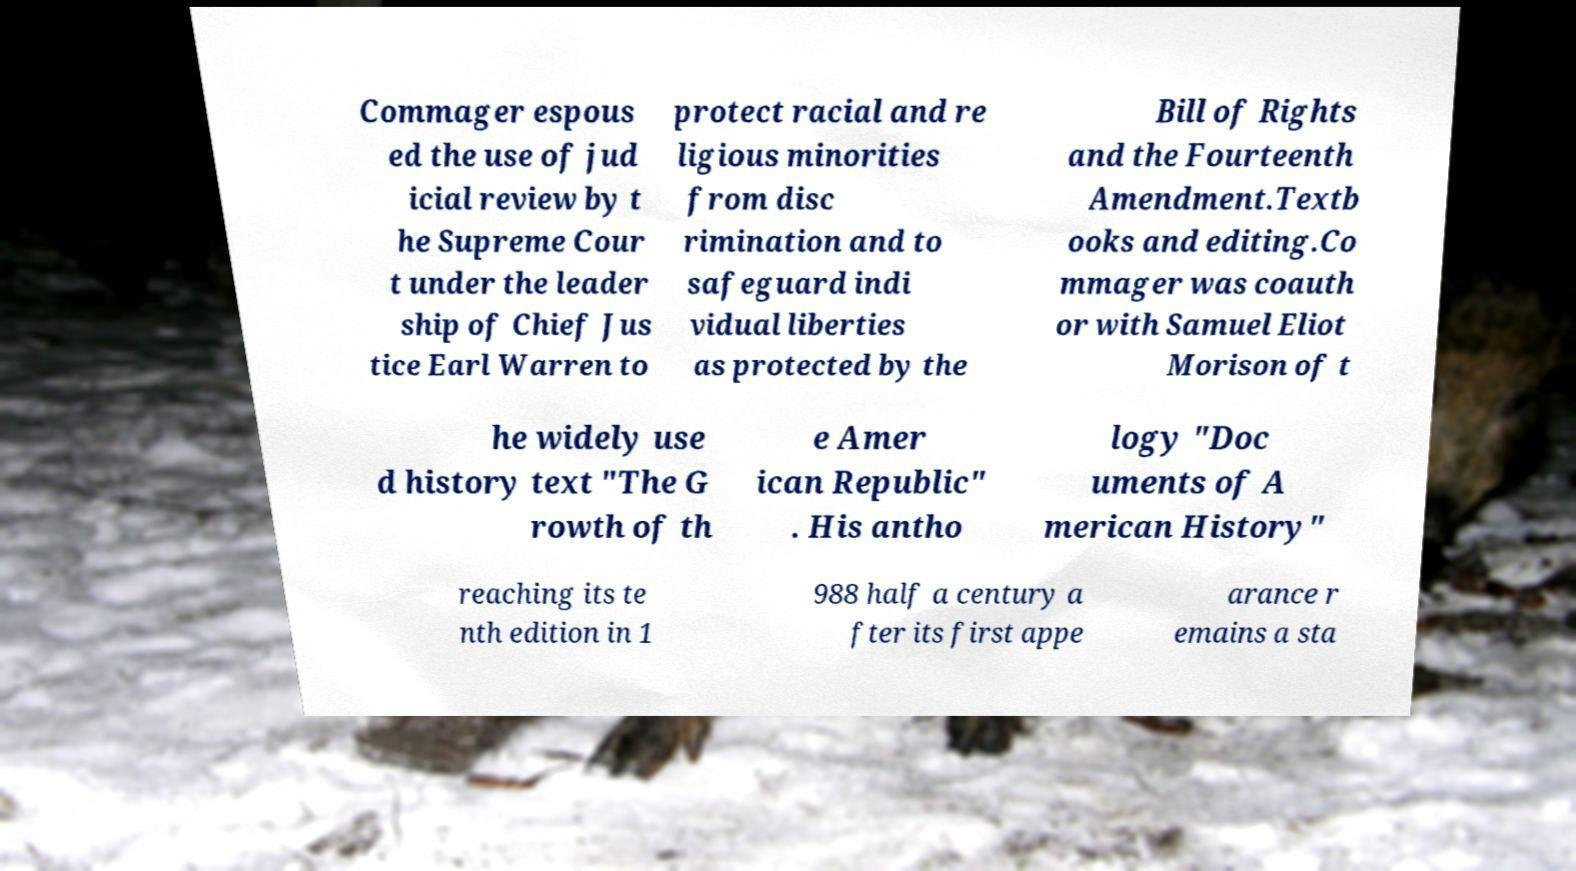Could you assist in decoding the text presented in this image and type it out clearly? Commager espous ed the use of jud icial review by t he Supreme Cour t under the leader ship of Chief Jus tice Earl Warren to protect racial and re ligious minorities from disc rimination and to safeguard indi vidual liberties as protected by the Bill of Rights and the Fourteenth Amendment.Textb ooks and editing.Co mmager was coauth or with Samuel Eliot Morison of t he widely use d history text "The G rowth of th e Amer ican Republic" . His antho logy "Doc uments of A merican History" reaching its te nth edition in 1 988 half a century a fter its first appe arance r emains a sta 